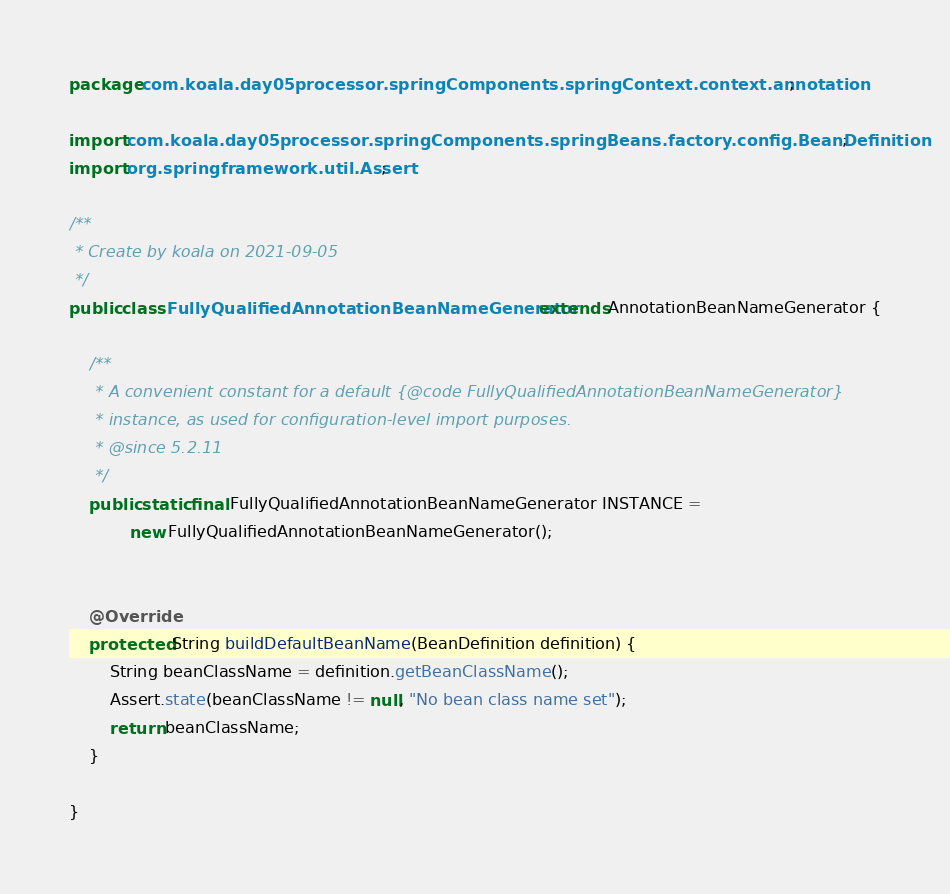<code> <loc_0><loc_0><loc_500><loc_500><_Java_>package com.koala.day05processor.springComponents.springContext.context.annotation;

import com.koala.day05processor.springComponents.springBeans.factory.config.BeanDefinition;
import org.springframework.util.Assert;

/**
 * Create by koala on 2021-09-05
 */
public class FullyQualifiedAnnotationBeanNameGenerator extends AnnotationBeanNameGenerator {

    /**
     * A convenient constant for a default {@code FullyQualifiedAnnotationBeanNameGenerator}
     * instance, as used for configuration-level import purposes.
     * @since 5.2.11
     */
    public static final FullyQualifiedAnnotationBeanNameGenerator INSTANCE =
            new FullyQualifiedAnnotationBeanNameGenerator();


    @Override
    protected String buildDefaultBeanName(BeanDefinition definition) {
        String beanClassName = definition.getBeanClassName();
        Assert.state(beanClassName != null, "No bean class name set");
        return beanClassName;
    }

}</code> 